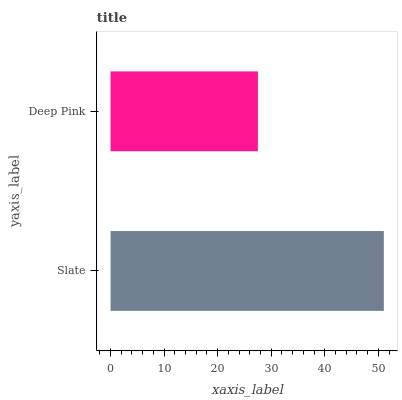Is Deep Pink the minimum?
Answer yes or no. Yes. Is Slate the maximum?
Answer yes or no. Yes. Is Deep Pink the maximum?
Answer yes or no. No. Is Slate greater than Deep Pink?
Answer yes or no. Yes. Is Deep Pink less than Slate?
Answer yes or no. Yes. Is Deep Pink greater than Slate?
Answer yes or no. No. Is Slate less than Deep Pink?
Answer yes or no. No. Is Slate the high median?
Answer yes or no. Yes. Is Deep Pink the low median?
Answer yes or no. Yes. Is Deep Pink the high median?
Answer yes or no. No. Is Slate the low median?
Answer yes or no. No. 